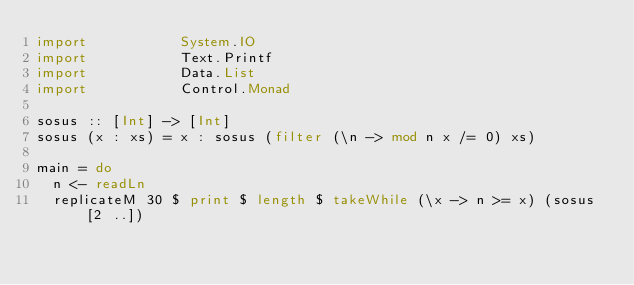<code> <loc_0><loc_0><loc_500><loc_500><_Haskell_>import           System.IO
import           Text.Printf
import           Data.List
import           Control.Monad

sosus :: [Int] -> [Int]
sosus (x : xs) = x : sosus (filter (\n -> mod n x /= 0) xs)

main = do
  n <- readLn
  replicateM 30 $ print $ length $ takeWhile (\x -> n >= x) (sosus [2 ..])
</code> 